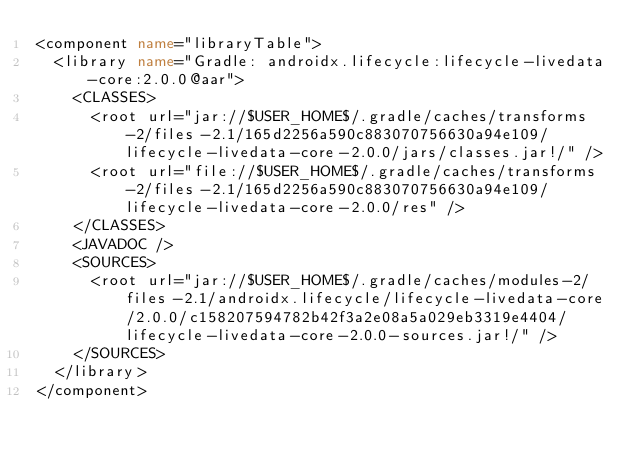Convert code to text. <code><loc_0><loc_0><loc_500><loc_500><_XML_><component name="libraryTable">
  <library name="Gradle: androidx.lifecycle:lifecycle-livedata-core:2.0.0@aar">
    <CLASSES>
      <root url="jar://$USER_HOME$/.gradle/caches/transforms-2/files-2.1/165d2256a590c883070756630a94e109/lifecycle-livedata-core-2.0.0/jars/classes.jar!/" />
      <root url="file://$USER_HOME$/.gradle/caches/transforms-2/files-2.1/165d2256a590c883070756630a94e109/lifecycle-livedata-core-2.0.0/res" />
    </CLASSES>
    <JAVADOC />
    <SOURCES>
      <root url="jar://$USER_HOME$/.gradle/caches/modules-2/files-2.1/androidx.lifecycle/lifecycle-livedata-core/2.0.0/c158207594782b42f3a2e08a5a029eb3319e4404/lifecycle-livedata-core-2.0.0-sources.jar!/" />
    </SOURCES>
  </library>
</component></code> 